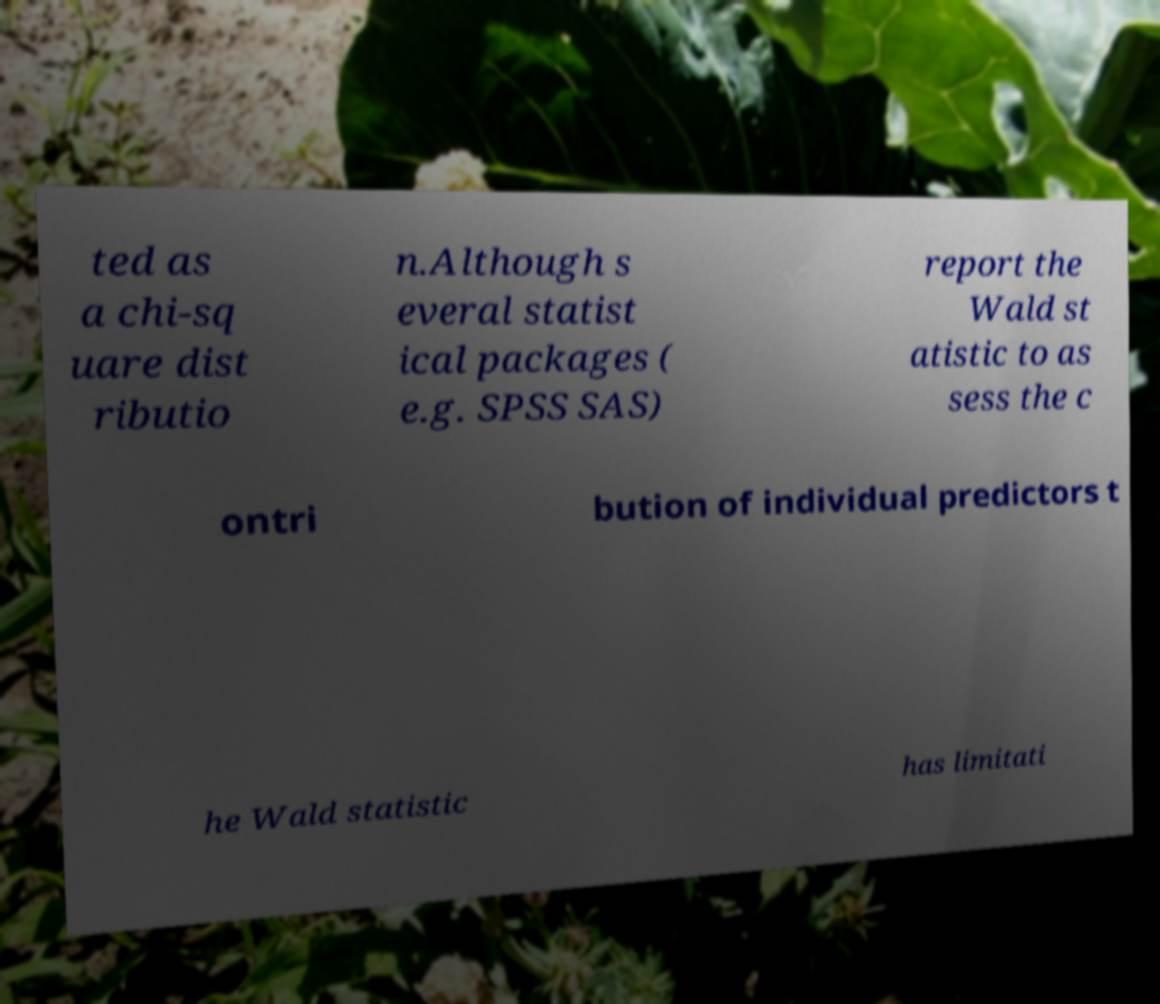Could you extract and type out the text from this image? ted as a chi-sq uare dist ributio n.Although s everal statist ical packages ( e.g. SPSS SAS) report the Wald st atistic to as sess the c ontri bution of individual predictors t he Wald statistic has limitati 